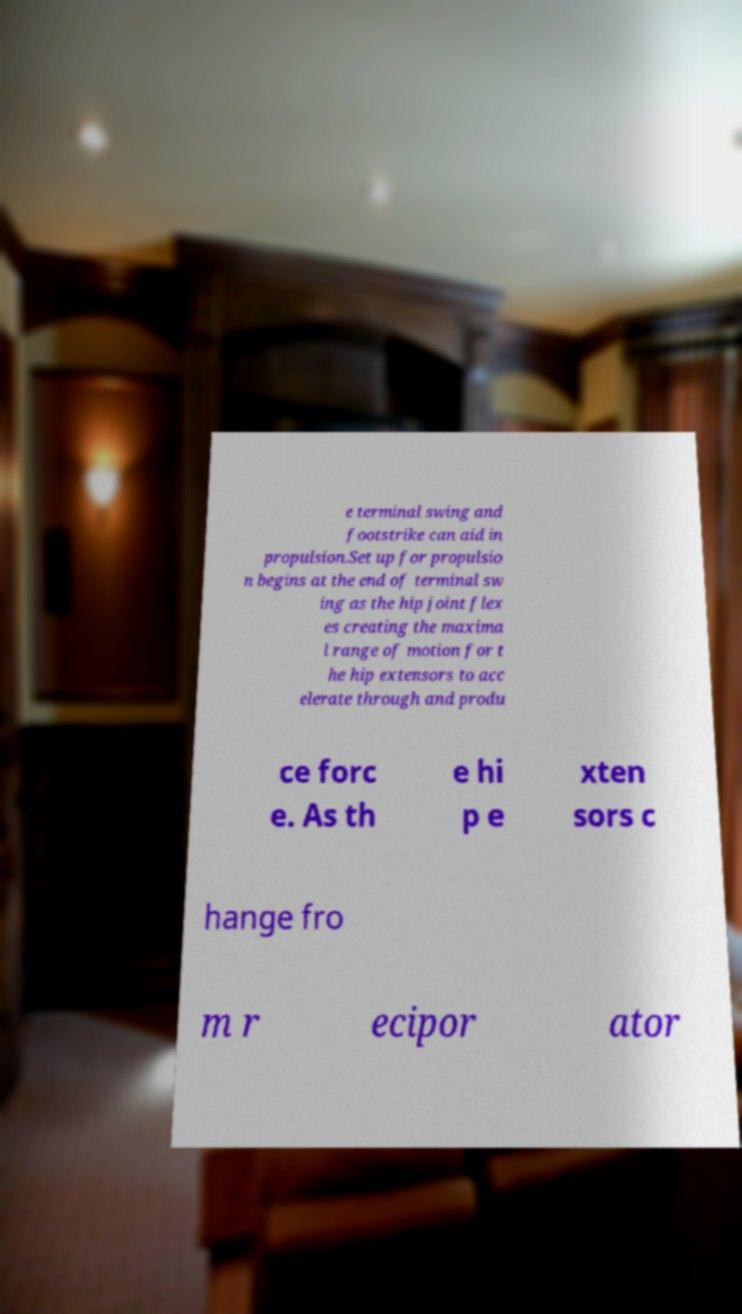I need the written content from this picture converted into text. Can you do that? e terminal swing and footstrike can aid in propulsion.Set up for propulsio n begins at the end of terminal sw ing as the hip joint flex es creating the maxima l range of motion for t he hip extensors to acc elerate through and produ ce forc e. As th e hi p e xten sors c hange fro m r ecipor ator 